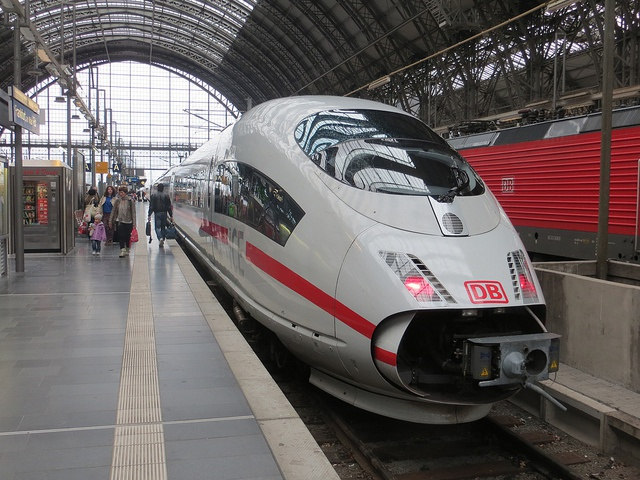Describe the objects in this image and their specific colors. I can see train in gray, black, darkgray, and lightgray tones, people in gray and black tones, people in gray, black, and darkblue tones, people in gray and black tones, and people in gray, black, and navy tones in this image. 